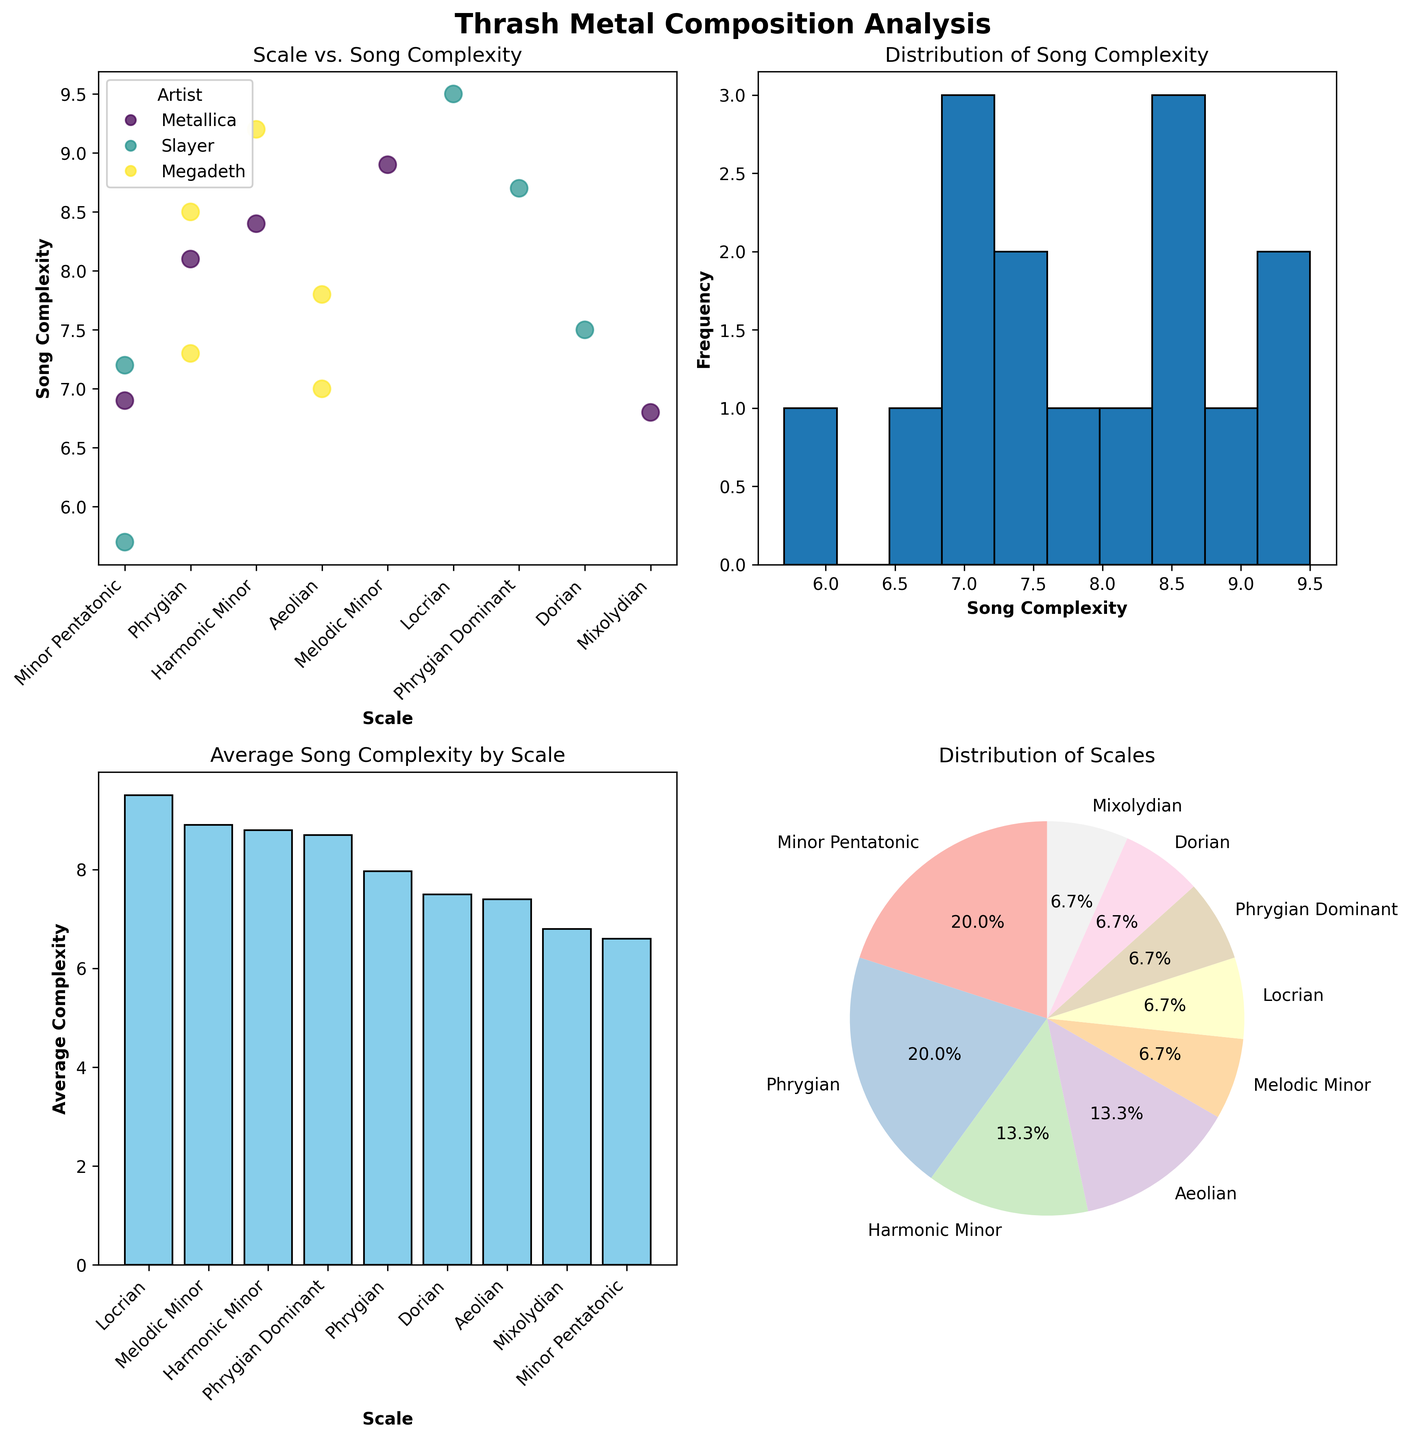Which scale has the highest average song complexity? By looking at the bar plot "Average Song Complexity by Scale," the highest bar represents the scale with the highest average song complexity. In the figure, the scale with the highest average complexity appears to be the Locrian scale.
Answer: Locrian Which artist is represented by the most data points in the scatter plot? Refer to the scatter plot legend which maps colors to artists. Count the number of data points for each artist’s color coding. Metallica has the most data points.
Answer: Metallica What is the title of the graph that shows the relationship between Scale and Song Complexity? Look at the main title of the scatter plot located at the top of the subplot. The title for this graph reads "Scale vs. Song Complexity."
Answer: Scale vs. Song Complexity How many compositions use the Minor Pentatonic scale? Refer to the pie chart "Distribution of Scales," and find the sector that represents the Minor Pentatonic scale. The label on this sector shows the percentage which can be converted to count. The sector for Minor Pentatonic shows 20%. Since there are 15 compositions, 20% of 15 is 3.
Answer: 3 What is the average complexity of songs that use the Phrygian scale? Examine the bar plot "Average Song Complexity by Scale" and locate the bar for the Phrygian scale. The height of this bar indicates the average complexity, which is approximately 8.0.
Answer: 8.0 Compare the song complexity of "Angel of Death" by Slayer and "Sweating Bullets" by Megadeth. Which one is more complex? Locate the data points for "Angel of Death" (Slayer, Scale: Phrygian) and "Sweating Bullets" (Megadeth, Scale: Mixolydian) on the scatter plot. "Angel of Death" has a complexity of 8.5, and "Sweating Bullets" has a complexity of 6.8. So, "Angel of Death" is more complex.
Answer: Angel of Death Which scale shows the most variability in song complexity? By observing the scatter plot, consider the spread of data points for each scale with high variance. The Phrygian scale shows high variability with complexity values ranging roughly from 7.3 to 8.5.
Answer: Phrygian Which composition has the highest song complexity? In the scatter plot, identify the data point with the highest y-value. The highest complexity value is 9.5, attributed to "Blackened" by Metallica using the Locrian scale.
Answer: Blackened 